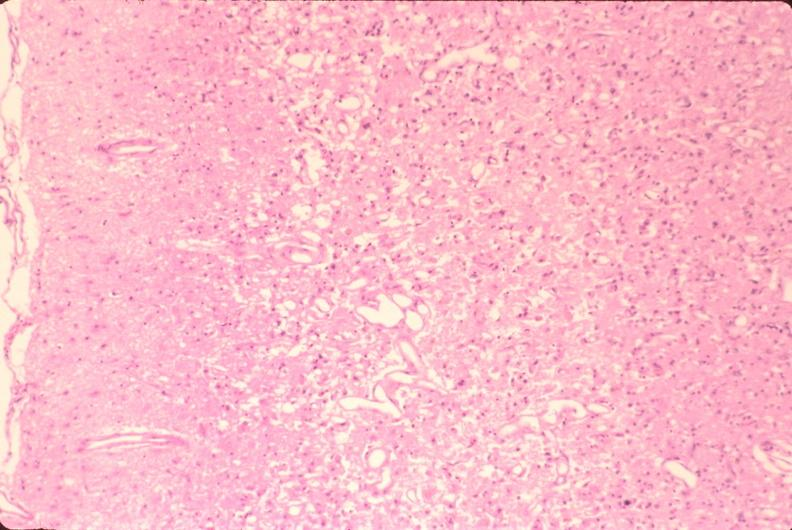what does this image show?
Answer the question using a single word or phrase. Brain 